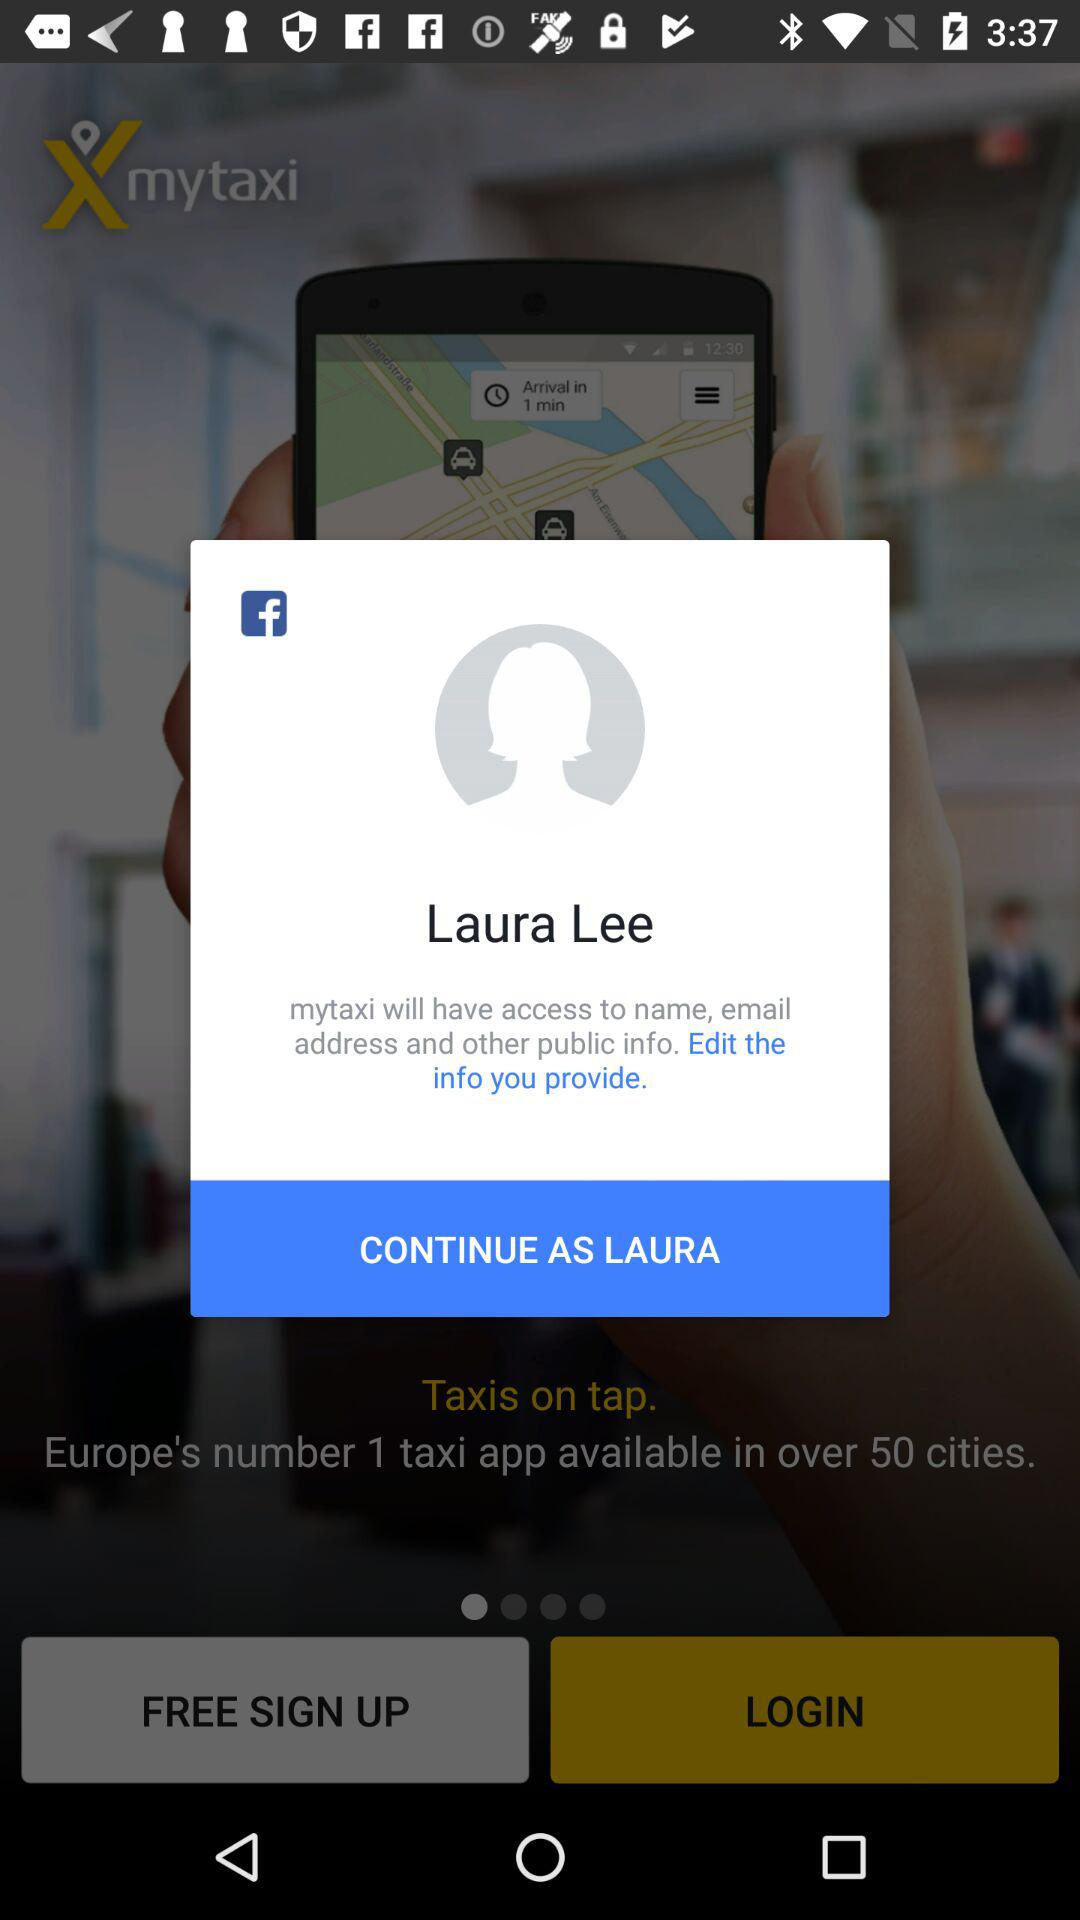Who will have access to the name and email address? The name and email address will be accessed by "mytaxi". 